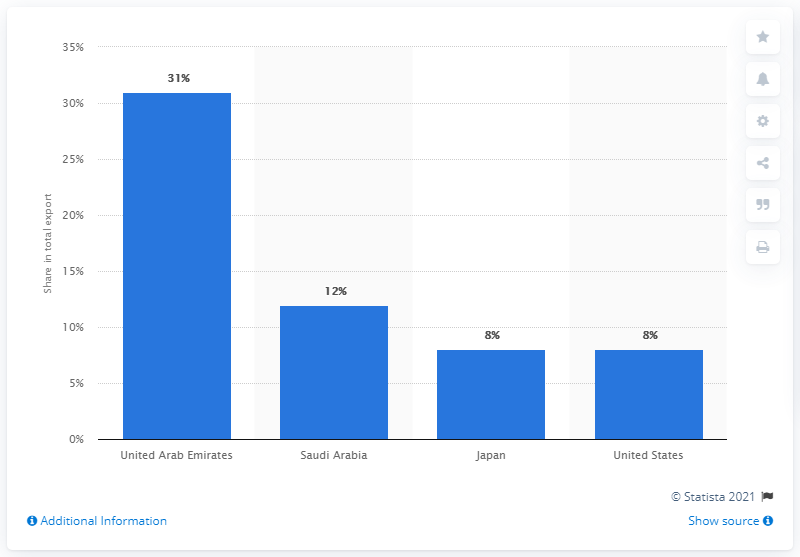Specify some key components in this picture. In 2019, the United Arab Emirates was Bahrain's primary export partner. 